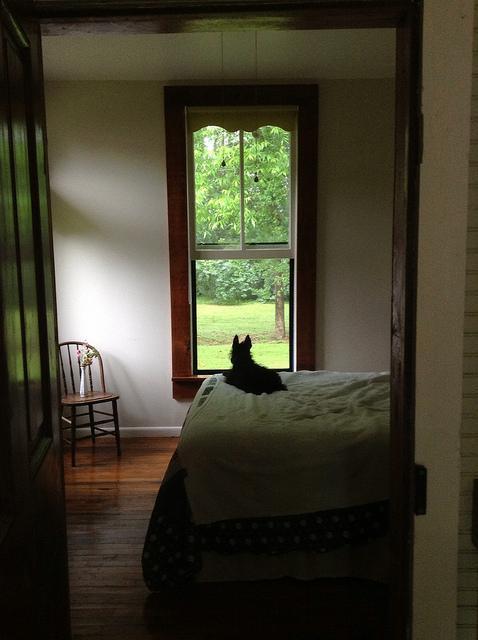How many animals are in this picture?
Give a very brief answer. 1. How many people can sleep in here?
Give a very brief answer. 2. How many pets?
Give a very brief answer. 1. 